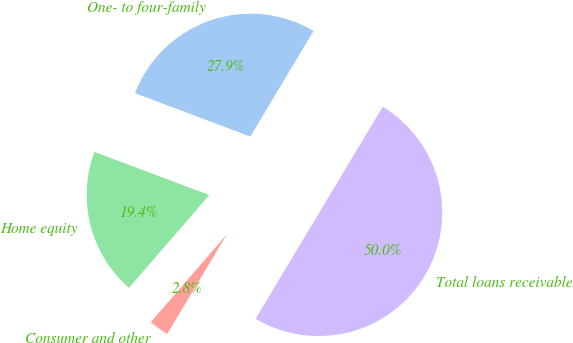Convert chart. <chart><loc_0><loc_0><loc_500><loc_500><pie_chart><fcel>One- to four-family<fcel>Home equity<fcel>Consumer and other<fcel>Total loans receivable<nl><fcel>27.88%<fcel>19.37%<fcel>2.76%<fcel>50.0%<nl></chart> 